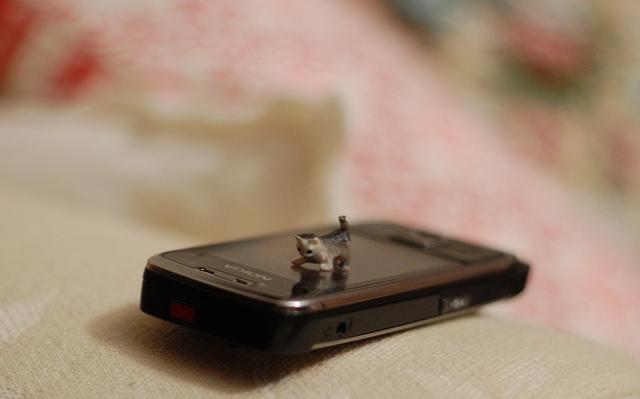Is the main object a cell phone?
Be succinct. Yes. Is the phone in one piece?
Short answer required. Yes. What figurine is sitting on the phone?
Concise answer only. Cat. 